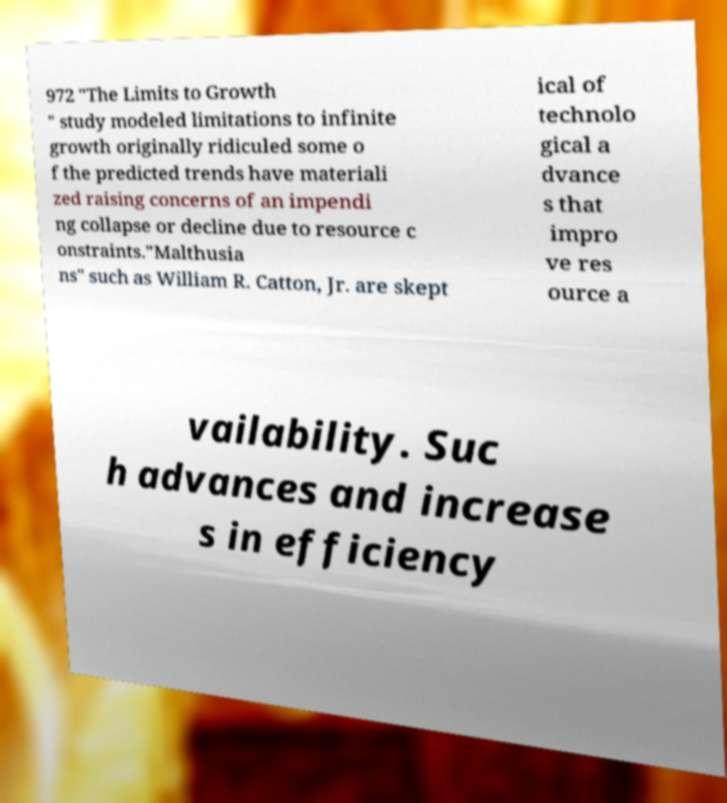Can you read and provide the text displayed in the image?This photo seems to have some interesting text. Can you extract and type it out for me? 972 "The Limits to Growth " study modeled limitations to infinite growth originally ridiculed some o f the predicted trends have materiali zed raising concerns of an impendi ng collapse or decline due to resource c onstraints."Malthusia ns" such as William R. Catton, Jr. are skept ical of technolo gical a dvance s that impro ve res ource a vailability. Suc h advances and increase s in efficiency 